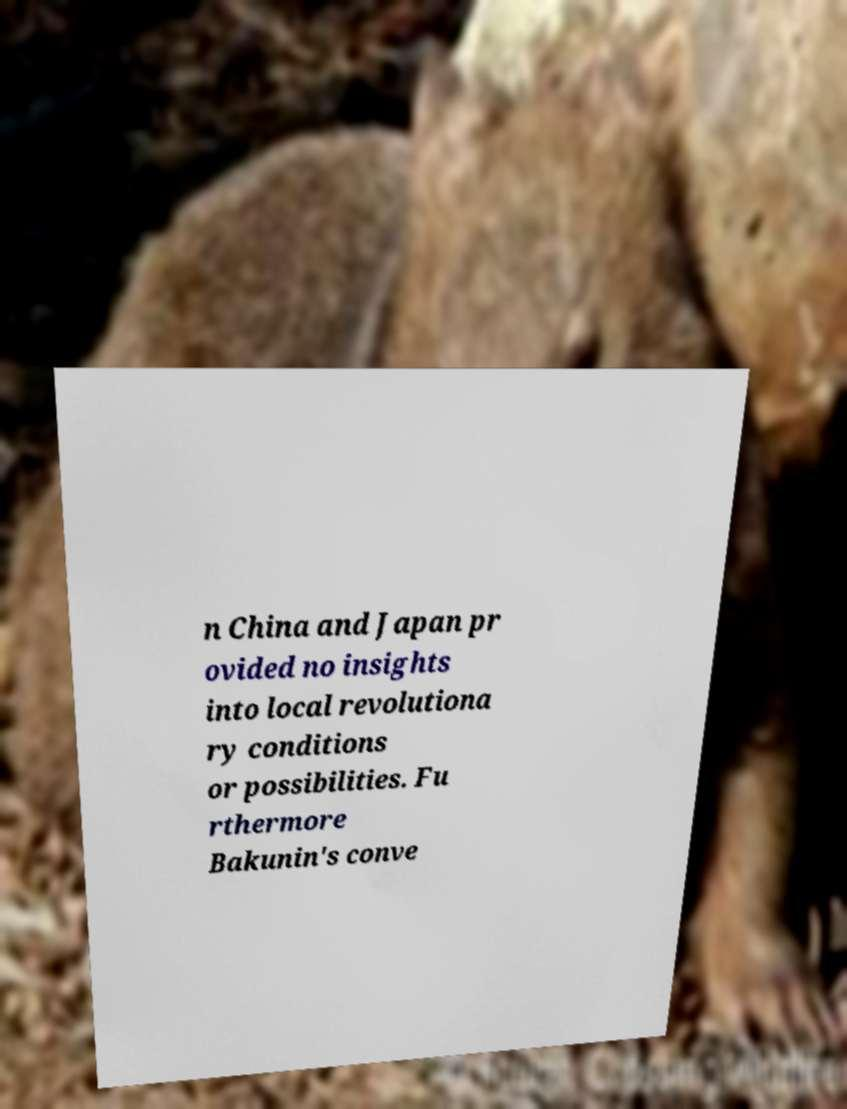Please read and relay the text visible in this image. What does it say? n China and Japan pr ovided no insights into local revolutiona ry conditions or possibilities. Fu rthermore Bakunin's conve 